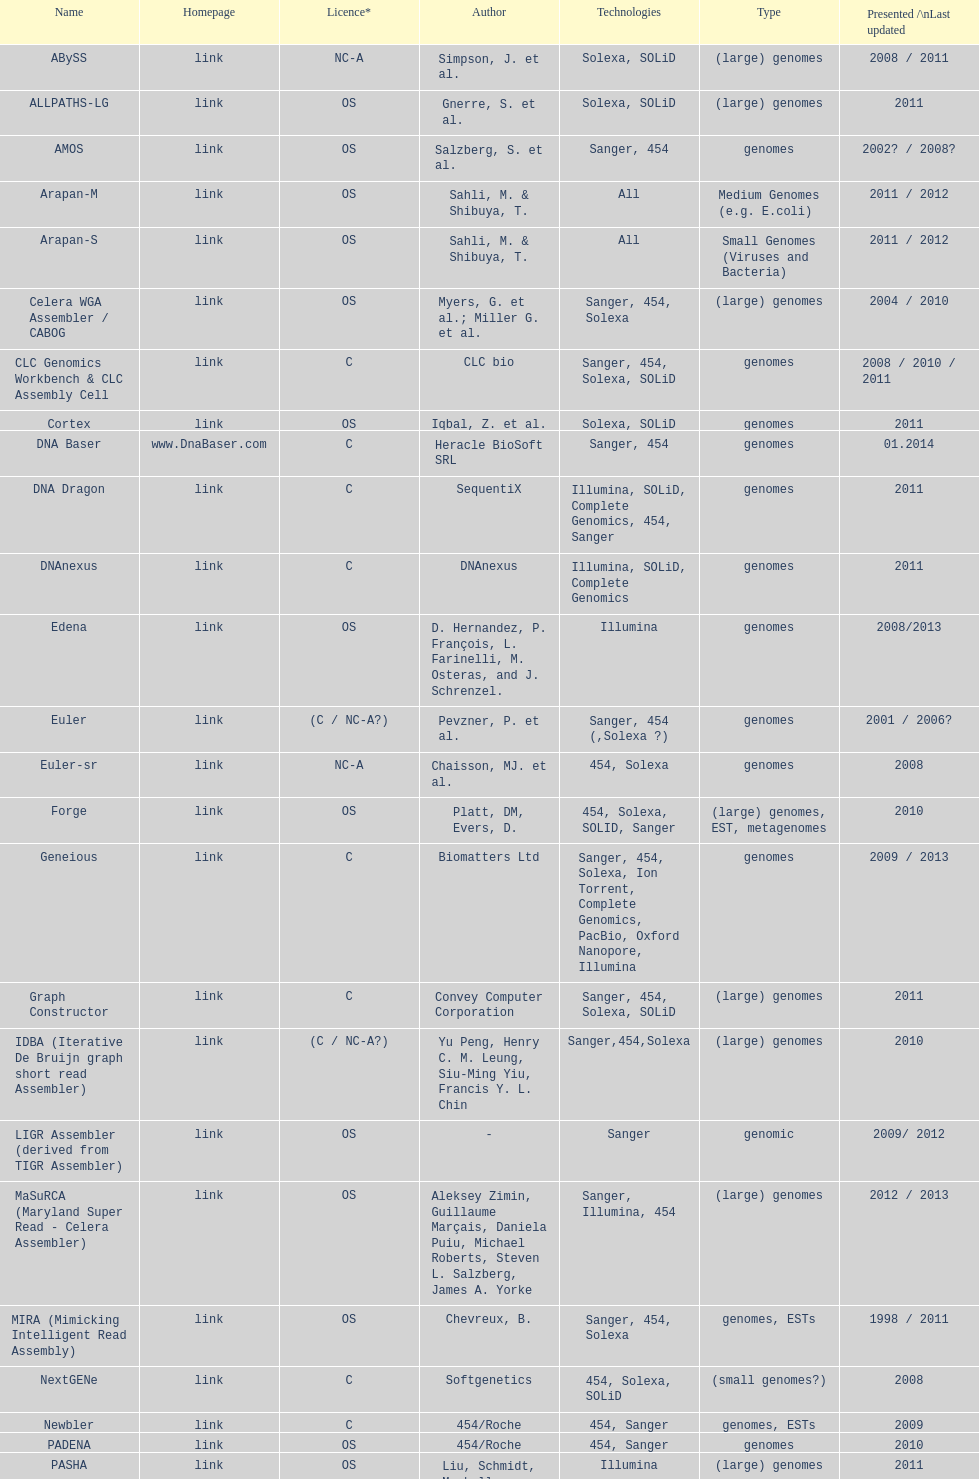When did the velvet receive its latest update? 2009. Write the full table. {'header': ['Name', 'Homepage', 'Licence*', 'Author', 'Technologies', 'Type', 'Presented /\\nLast updated'], 'rows': [['ABySS', 'link', 'NC-A', 'Simpson, J. et al.', 'Solexa, SOLiD', '(large) genomes', '2008 / 2011'], ['ALLPATHS-LG', 'link', 'OS', 'Gnerre, S. et al.', 'Solexa, SOLiD', '(large) genomes', '2011'], ['AMOS', 'link', 'OS', 'Salzberg, S. et al.', 'Sanger, 454', 'genomes', '2002? / 2008?'], ['Arapan-M', 'link', 'OS', 'Sahli, M. & Shibuya, T.', 'All', 'Medium Genomes (e.g. E.coli)', '2011 / 2012'], ['Arapan-S', 'link', 'OS', 'Sahli, M. & Shibuya, T.', 'All', 'Small Genomes (Viruses and Bacteria)', '2011 / 2012'], ['Celera WGA Assembler / CABOG', 'link', 'OS', 'Myers, G. et al.; Miller G. et al.', 'Sanger, 454, Solexa', '(large) genomes', '2004 / 2010'], ['CLC Genomics Workbench & CLC Assembly Cell', 'link', 'C', 'CLC bio', 'Sanger, 454, Solexa, SOLiD', 'genomes', '2008 / 2010 / 2011'], ['Cortex', 'link', 'OS', 'Iqbal, Z. et al.', 'Solexa, SOLiD', 'genomes', '2011'], ['DNA Baser', 'www.DnaBaser.com', 'C', 'Heracle BioSoft SRL', 'Sanger, 454', 'genomes', '01.2014'], ['DNA Dragon', 'link', 'C', 'SequentiX', 'Illumina, SOLiD, Complete Genomics, 454, Sanger', 'genomes', '2011'], ['DNAnexus', 'link', 'C', 'DNAnexus', 'Illumina, SOLiD, Complete Genomics', 'genomes', '2011'], ['Edena', 'link', 'OS', 'D. Hernandez, P. François, L. Farinelli, M. Osteras, and J. Schrenzel.', 'Illumina', 'genomes', '2008/2013'], ['Euler', 'link', '(C / NC-A?)', 'Pevzner, P. et al.', 'Sanger, 454 (,Solexa\xa0?)', 'genomes', '2001 / 2006?'], ['Euler-sr', 'link', 'NC-A', 'Chaisson, MJ. et al.', '454, Solexa', 'genomes', '2008'], ['Forge', 'link', 'OS', 'Platt, DM, Evers, D.', '454, Solexa, SOLID, Sanger', '(large) genomes, EST, metagenomes', '2010'], ['Geneious', 'link', 'C', 'Biomatters Ltd', 'Sanger, 454, Solexa, Ion Torrent, Complete Genomics, PacBio, Oxford Nanopore, Illumina', 'genomes', '2009 / 2013'], ['Graph Constructor', 'link', 'C', 'Convey Computer Corporation', 'Sanger, 454, Solexa, SOLiD', '(large) genomes', '2011'], ['IDBA (Iterative De Bruijn graph short read Assembler)', 'link', '(C / NC-A?)', 'Yu Peng, Henry C. M. Leung, Siu-Ming Yiu, Francis Y. L. Chin', 'Sanger,454,Solexa', '(large) genomes', '2010'], ['LIGR Assembler (derived from TIGR Assembler)', 'link', 'OS', '-', 'Sanger', 'genomic', '2009/ 2012'], ['MaSuRCA (Maryland Super Read - Celera Assembler)', 'link', 'OS', 'Aleksey Zimin, Guillaume Marçais, Daniela Puiu, Michael Roberts, Steven L. Salzberg, James A. Yorke', 'Sanger, Illumina, 454', '(large) genomes', '2012 / 2013'], ['MIRA (Mimicking Intelligent Read Assembly)', 'link', 'OS', 'Chevreux, B.', 'Sanger, 454, Solexa', 'genomes, ESTs', '1998 / 2011'], ['NextGENe', 'link', 'C', 'Softgenetics', '454, Solexa, SOLiD', '(small genomes?)', '2008'], ['Newbler', 'link', 'C', '454/Roche', '454, Sanger', 'genomes, ESTs', '2009'], ['PADENA', 'link', 'OS', '454/Roche', '454, Sanger', 'genomes', '2010'], ['PASHA', 'link', 'OS', 'Liu, Schmidt, Maskell', 'Illumina', '(large) genomes', '2011'], ['Phrap', 'link', 'C / NC-A', 'Green, P.', 'Sanger, 454, Solexa', 'genomes', '1994 / 2008'], ['TIGR Assembler', 'link', 'OS', '-', 'Sanger', 'genomic', '1995 / 2003'], ['Ray', 'link', 'OS [GNU General Public License]', 'Sébastien Boisvert, François Laviolette & Jacques Corbeil.', 'Illumina, mix of Illumina and 454, paired or not', 'genomes', '2010'], ['Sequencher', 'link', 'C', 'Gene Codes Corporation', 'traditional and next generation sequence data', 'genomes', '1991 / 2009 / 2011'], ['SeqMan NGen', 'link', 'C', 'DNASTAR', 'Illumina, ABI SOLiD, Roche 454, Ion Torrent, Solexa, Sanger', '(large) genomes, exomes, transcriptomes, metagenomes, ESTs', '2007 / 2011'], ['SGA', 'link', 'OS', 'Simpson, J.T. et al.', 'Illumina, Sanger (Roche 454?, Ion Torrent?)', '(large) genomes', '2011 / 2012'], ['SHARCGS', 'link', 'OS', 'Dohm et al.', 'Solexa', '(small) genomes', '2007 / 2007'], ['SOPRA', 'link', 'OS', 'Dayarian, A. et al.', 'Illumina, SOLiD, Sanger, 454', 'genomes', '2010 / 2011'], ['SparseAssembler', 'link', 'OS', 'Ye, C. et al.', 'Illumina, 454, Ion torrent', '(large) genomes', '2012 / 2012'], ['SSAKE', 'link', 'OS', 'Warren, R. et al.', 'Solexa (SOLiD? Helicos?)', '(small) genomes', '2007 / 2007'], ['SOAPdenovo', 'link', 'OS', 'Li, R. et al.', 'Solexa', 'genomes', '2009 / 2009'], ['SPAdes', 'link', 'OS', 'Bankevich, A et al.', 'Illumina, Solexa', '(small) genomes, single-cell', '2012 / 2013'], ['Staden gap4 package', 'link', 'OS', 'Staden et al.', 'Sanger', 'BACs (, small genomes?)', '1991 / 2008'], ['Taipan', 'link', 'OS', 'Schmidt, B. et al.', 'Illumina', '(small) genomes', '2009'], ['VCAKE', 'link', 'OS', 'Jeck, W. et al.', 'Solexa (SOLiD?, Helicos?)', '(small) genomes', '2007 / 2007'], ['Phusion assembler', 'link', 'OS', 'Mullikin JC, et al.', 'Sanger', '(large) genomes', '2003'], ['Quality Value Guided SRA (QSRA)', 'link', 'OS', 'Bryant DW, et al.', 'Sanger, Solexa', 'genomes', '2009'], ['Velvet', 'link', 'OS', 'Zerbino, D. et al.', 'Sanger, 454, Solexa, SOLiD', '(small) genomes', '2007 / 2009']]} 